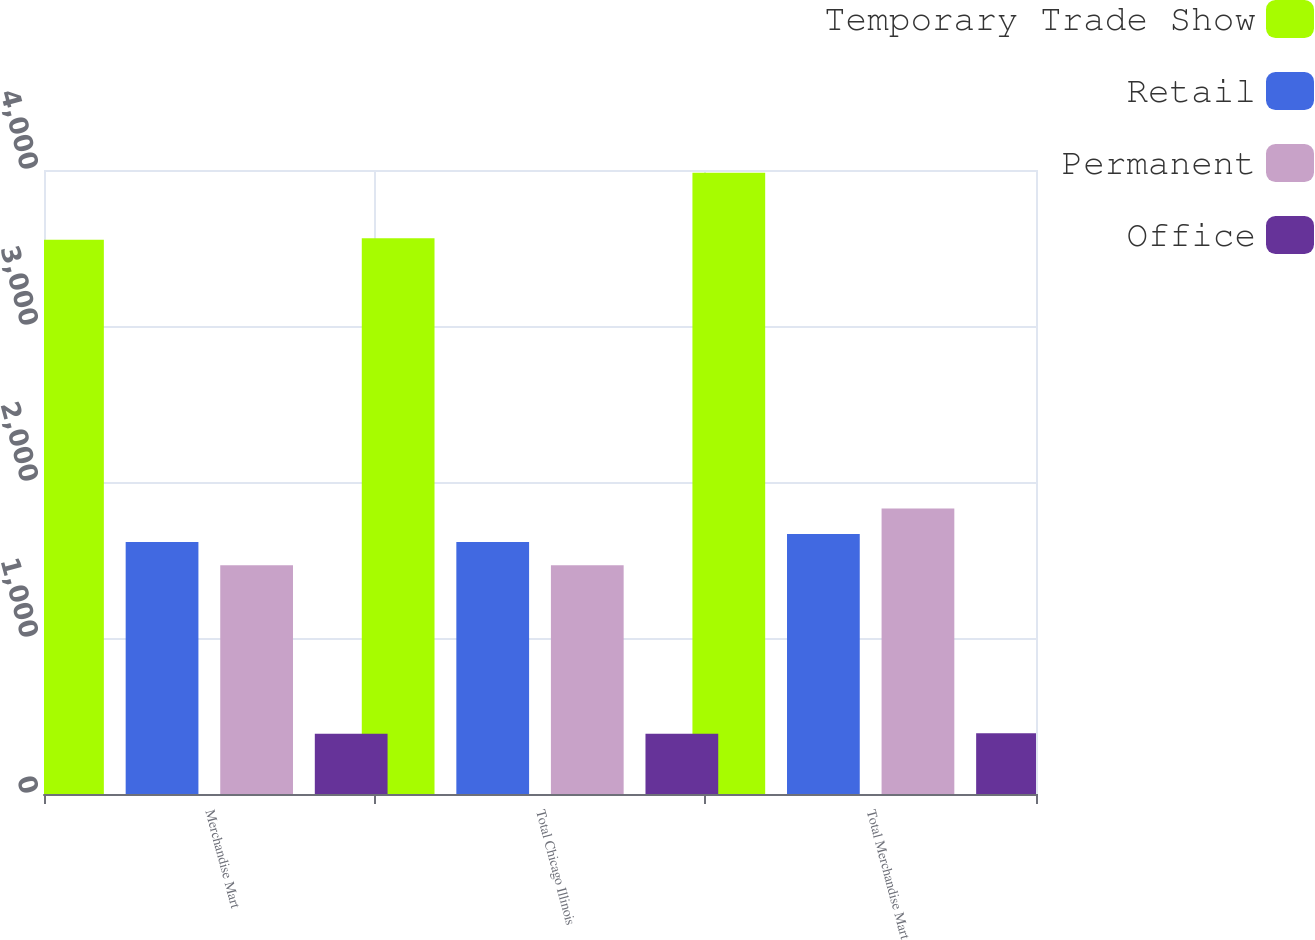Convert chart. <chart><loc_0><loc_0><loc_500><loc_500><stacked_bar_chart><ecel><fcel>Merchandise Mart<fcel>Total Chicago Illinois<fcel>Total Merchandise Mart<nl><fcel>Temporary Trade Show<fcel>3553<fcel>3563<fcel>3982<nl><fcel>Retail<fcel>1615<fcel>1615<fcel>1667<nl><fcel>Permanent<fcel>1467<fcel>1467<fcel>1830<nl><fcel>Office<fcel>386<fcel>386<fcel>390<nl></chart> 